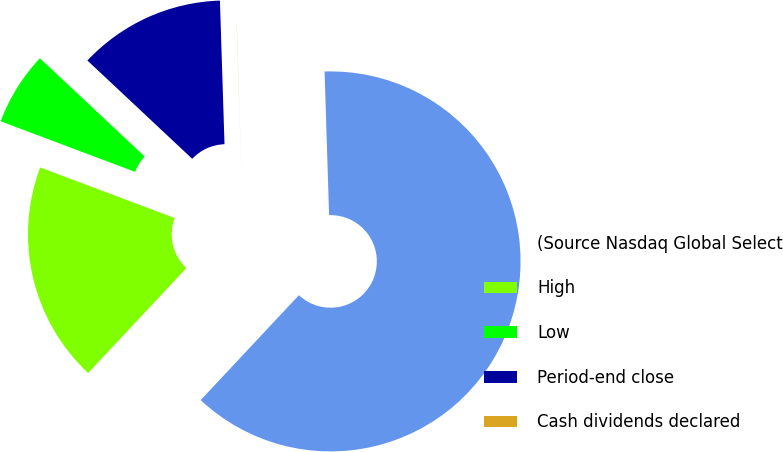<chart> <loc_0><loc_0><loc_500><loc_500><pie_chart><fcel>(Source Nasdaq Global Select<fcel>High<fcel>Low<fcel>Period-end close<fcel>Cash dividends declared<nl><fcel>62.47%<fcel>18.75%<fcel>6.26%<fcel>12.5%<fcel>0.01%<nl></chart> 